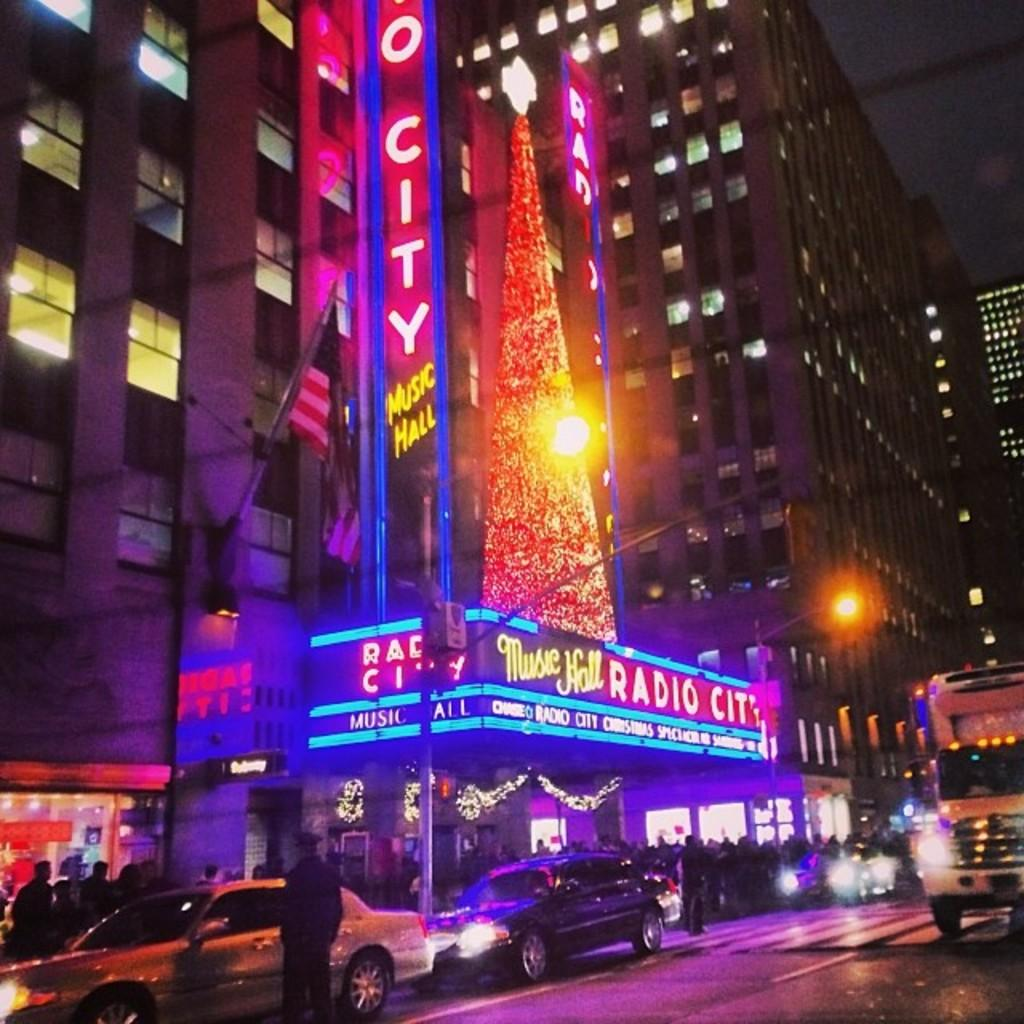What type of structures can be seen in the image? There are buildings in the image. What is the flag attached to in the image? The flag is attached to something in the image, but the specific object is not mentioned in the facts. What are the boards used for in the image? The purpose of the boards in the image is not mentioned in the facts. What can be seen illuminated in the image? There are lights in the image, which suggests that some objects or areas are illuminated. What type of transportation is present in the image? There are vehicles in the image. Who or what is present in the image? There are people in the image. Where is the playground located in the image? There is no mention of a playground in the image. What type of engine is powering the vehicles in the image? The type of engine powering the vehicles in the image is not mentioned in the facts. 